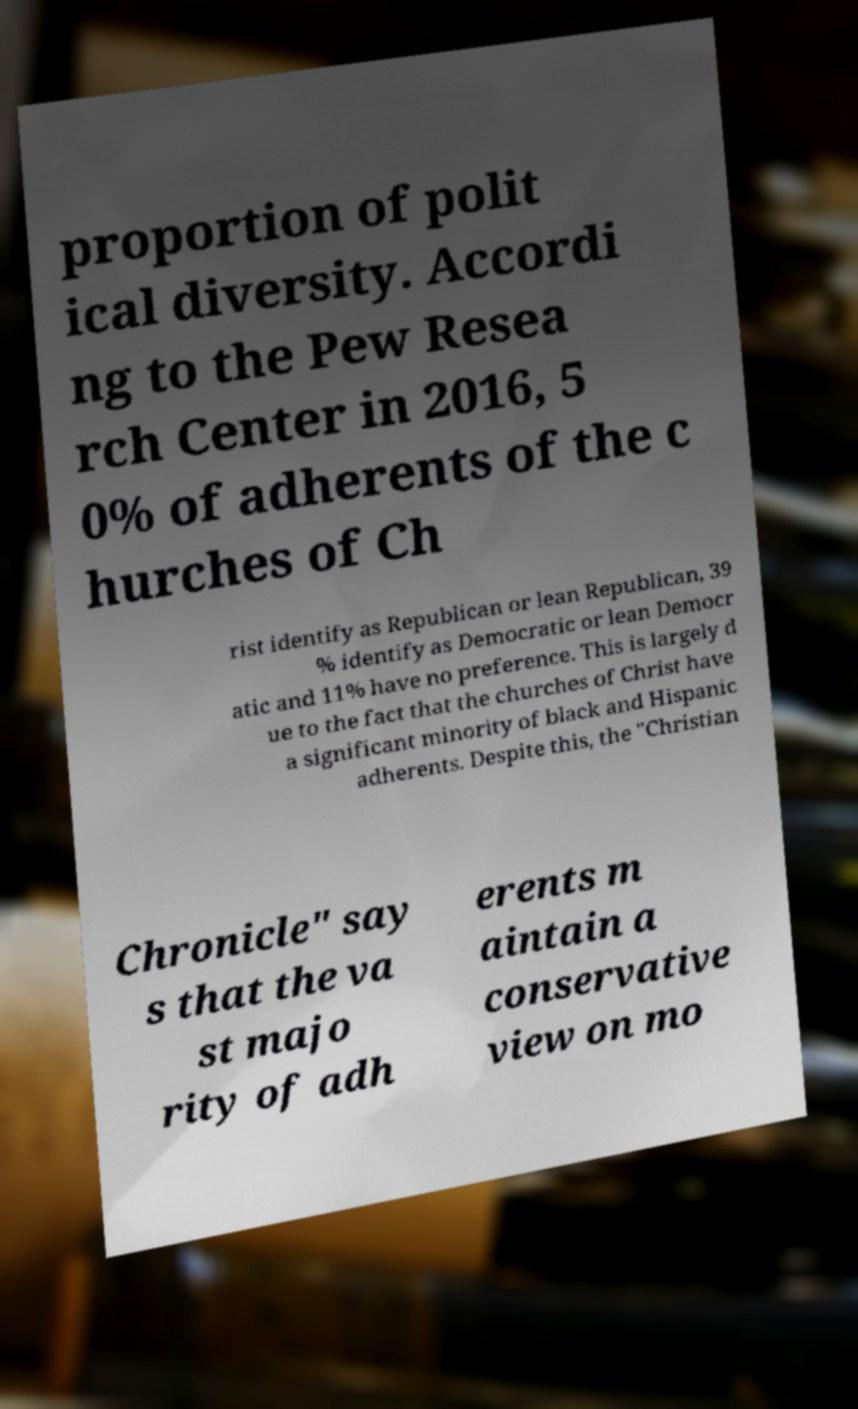I need the written content from this picture converted into text. Can you do that? proportion of polit ical diversity. Accordi ng to the Pew Resea rch Center in 2016, 5 0% of adherents of the c hurches of Ch rist identify as Republican or lean Republican, 39 % identify as Democratic or lean Democr atic and 11% have no preference. This is largely d ue to the fact that the churches of Christ have a significant minority of black and Hispanic adherents. Despite this, the "Christian Chronicle" say s that the va st majo rity of adh erents m aintain a conservative view on mo 